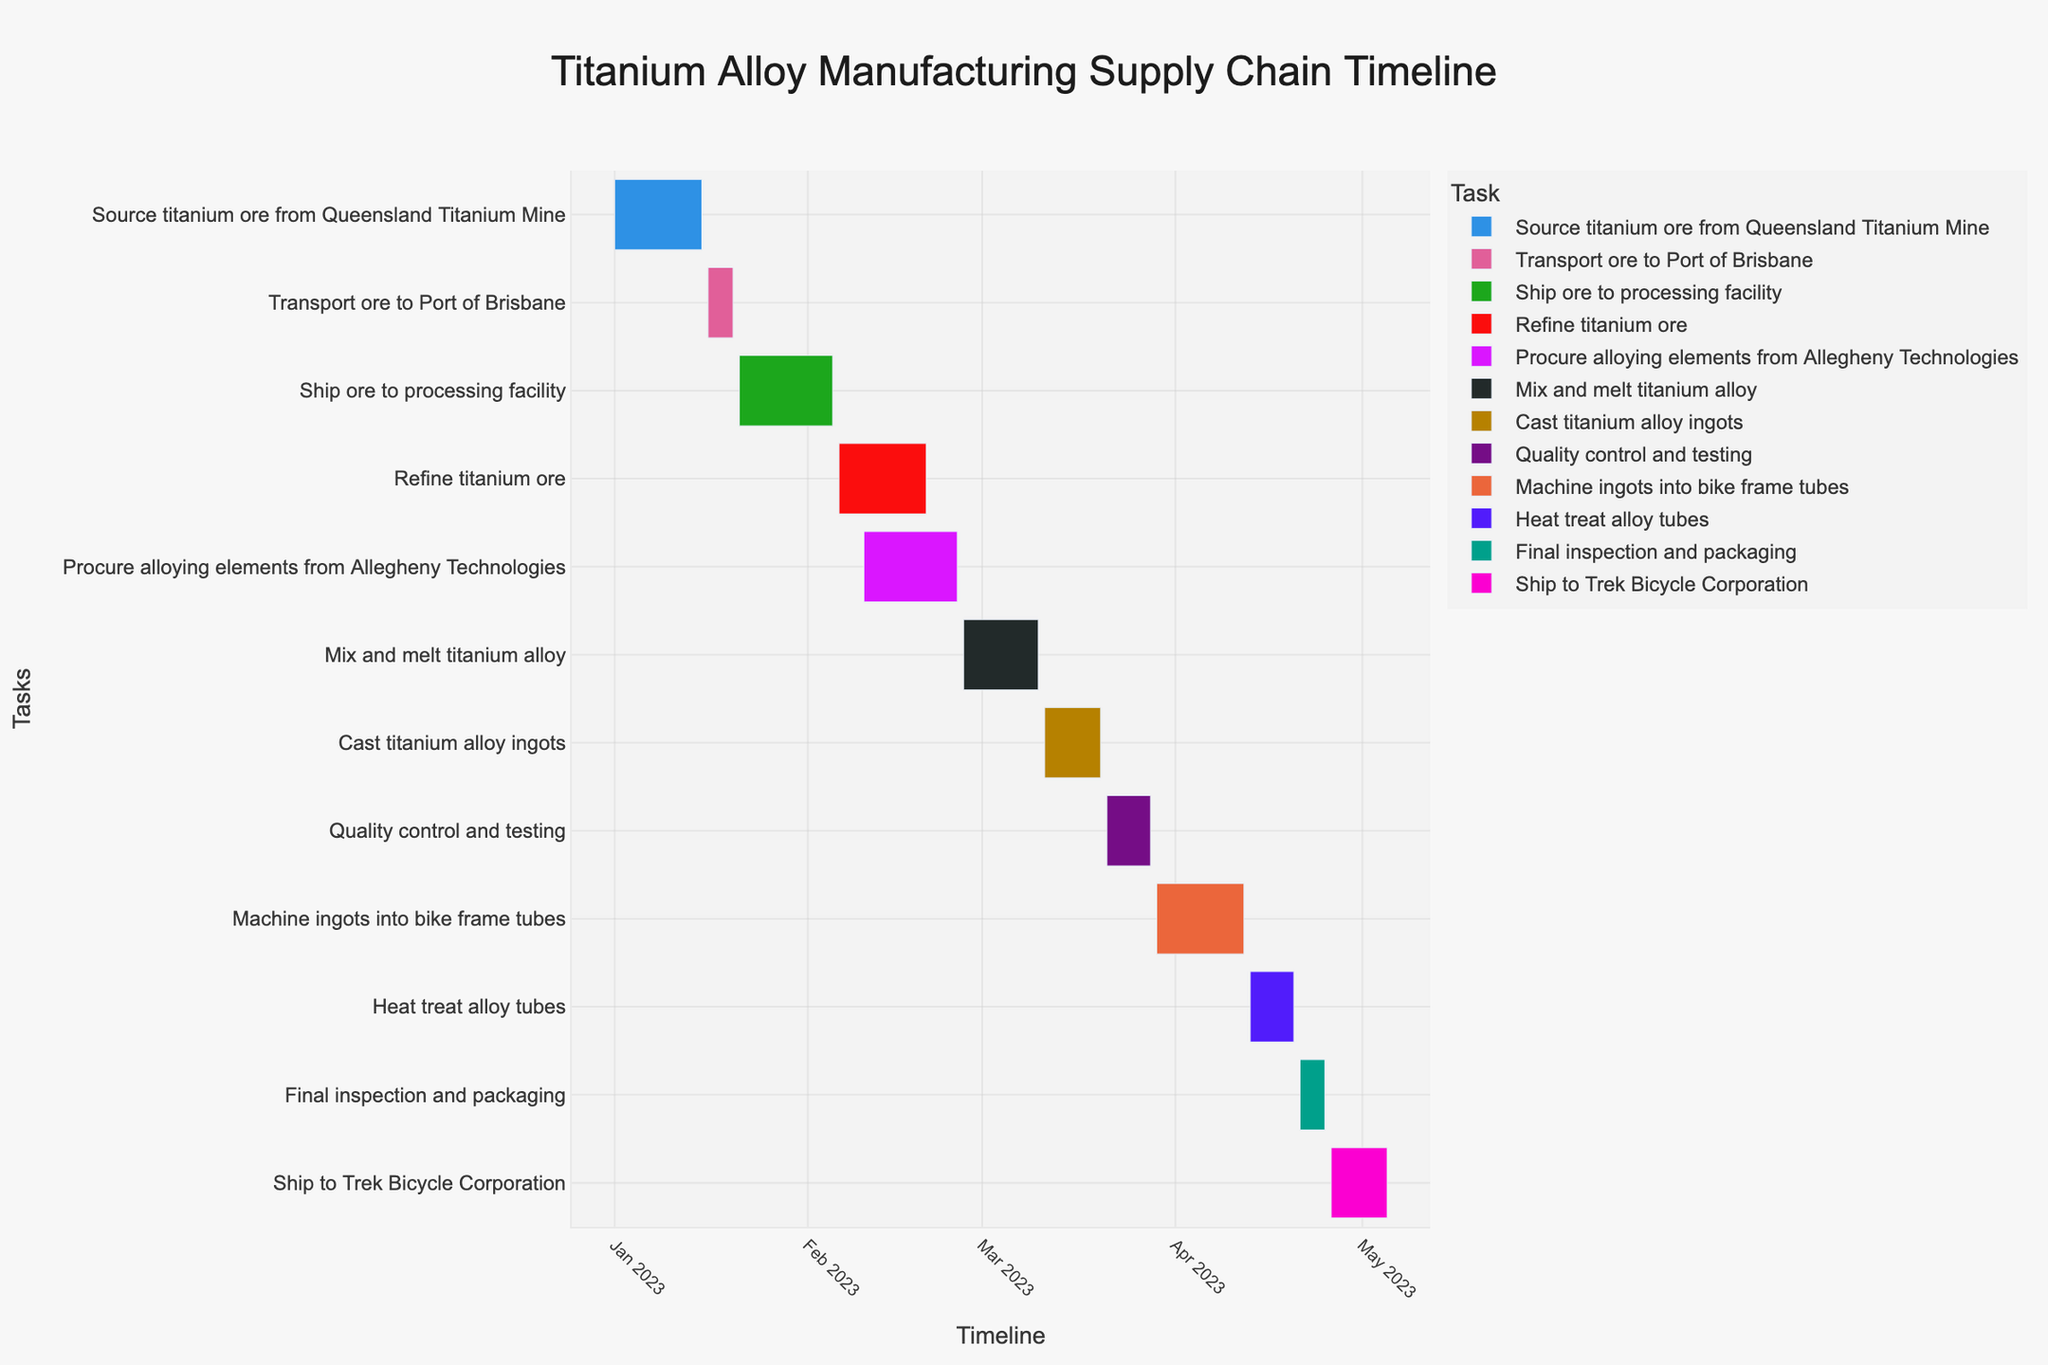What's the title of the Gantt Chart? Look at the text displayed prominently at the top of the figure. The title describes the overall purpose of the Gantt Chart.
Answer: Titanium Alloy Manufacturing Supply Chain Timeline Which task starts first in the supply chain process? Identify the task with the earliest start date at the top of the chart.
Answer: Source titanium ore from Queensland Titanium Mine How many days are allocated to refine titanium ore? Find the start and end dates of the "Refine titanium ore" task and calculate the difference in days.
Answer: 15 days What tasks are happening concurrently with refining titanium ore? Check the timeline for tasks that overlap with the "Refine titanium ore" task dates.
Answer: Procure alloying elements from Allegheny Technologies Calculate the total duration of the supply chain process from sourcing raw materials to delivering finished products. Determine the start date of the first task and the end date of the last task, then calculate the total number of days.
Answer: 125 days Which task takes the longest duration to complete? Compare the durations of all tasks by examining the length of the bars representing each task.
Answer: Ship ore to processing facility During which period does the "Quality control and testing" task occur? Locate the "Quality control and testing" task and read the start and end dates.
Answer: March 21 to March 28, 2023 What is the final task before shipping to Trek Bicycle Corporation? Look at the sequence of tasks and find the one immediately before the shipping task.
Answer: Final inspection and packaging Which task directly follows the heat treat alloy tubes? Identify the task that comes immediately after the "Heat treat alloy tubes" task.
Answer: Final inspection and packaging What is the duration during which the titanium alloy tubes are being machined into bike frame tubes? Find the start and end dates for the "Machine ingots into bike frame tubes" task and calculate the difference in days.
Answer: 15 days 